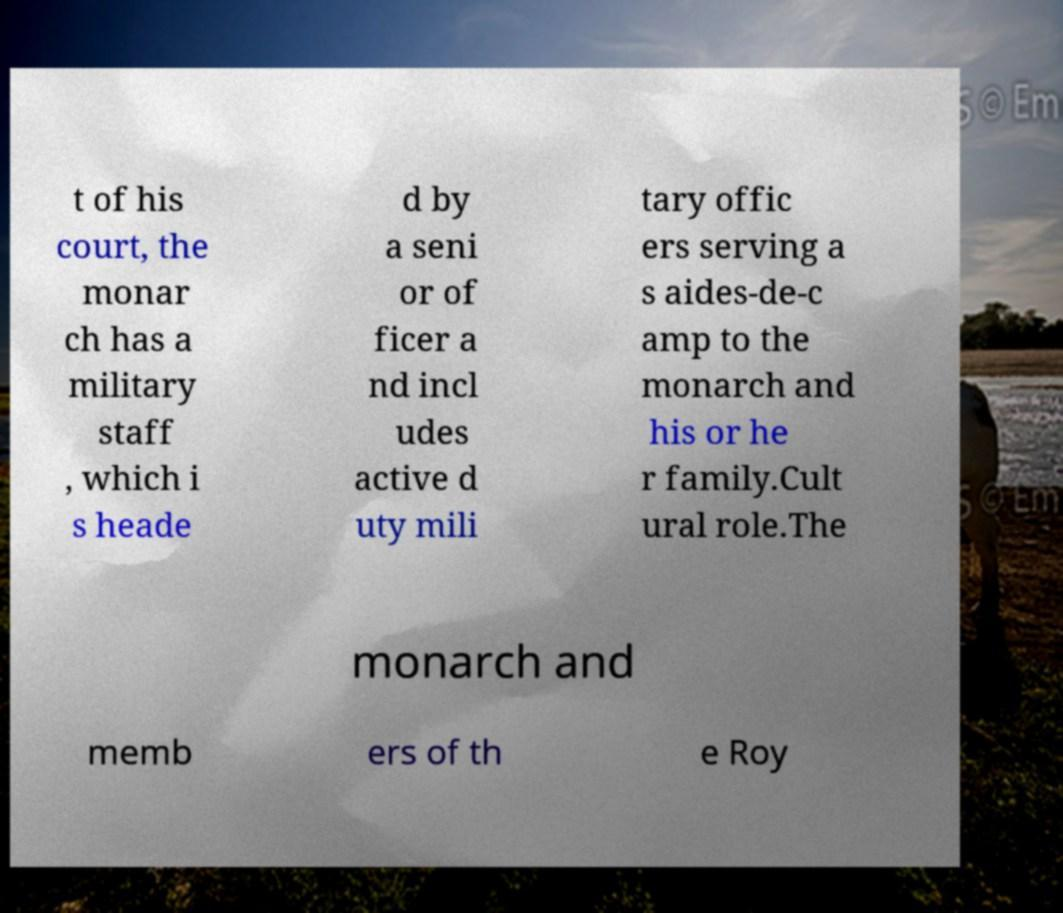What messages or text are displayed in this image? I need them in a readable, typed format. t of his court, the monar ch has a military staff , which i s heade d by a seni or of ficer a nd incl udes active d uty mili tary offic ers serving a s aides-de-c amp to the monarch and his or he r family.Cult ural role.The monarch and memb ers of th e Roy 